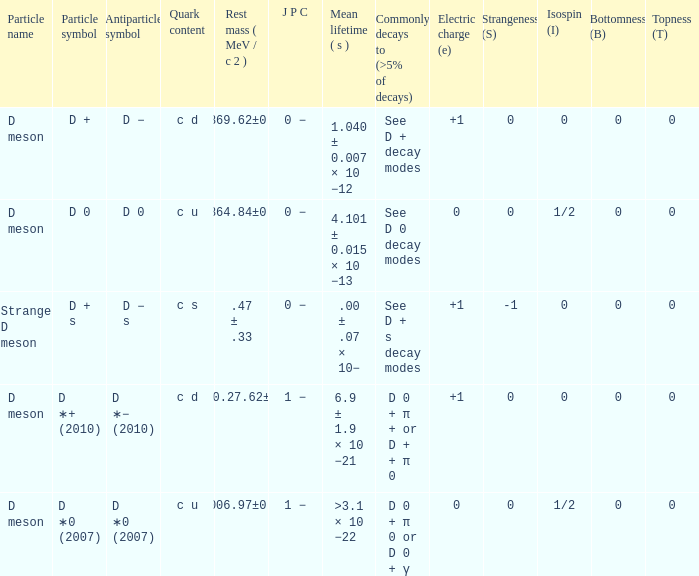What is the antiparticle symbol with a rest mess (mev/c2) of .47 ± .33? D − s. 